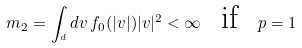<formula> <loc_0><loc_0><loc_500><loc_500>m _ { 2 } = \int _ { \real ^ { d } } d v \, f _ { 0 } ( | v | ) | v | ^ { 2 } < \infty \ \text { if } \ p = 1</formula> 